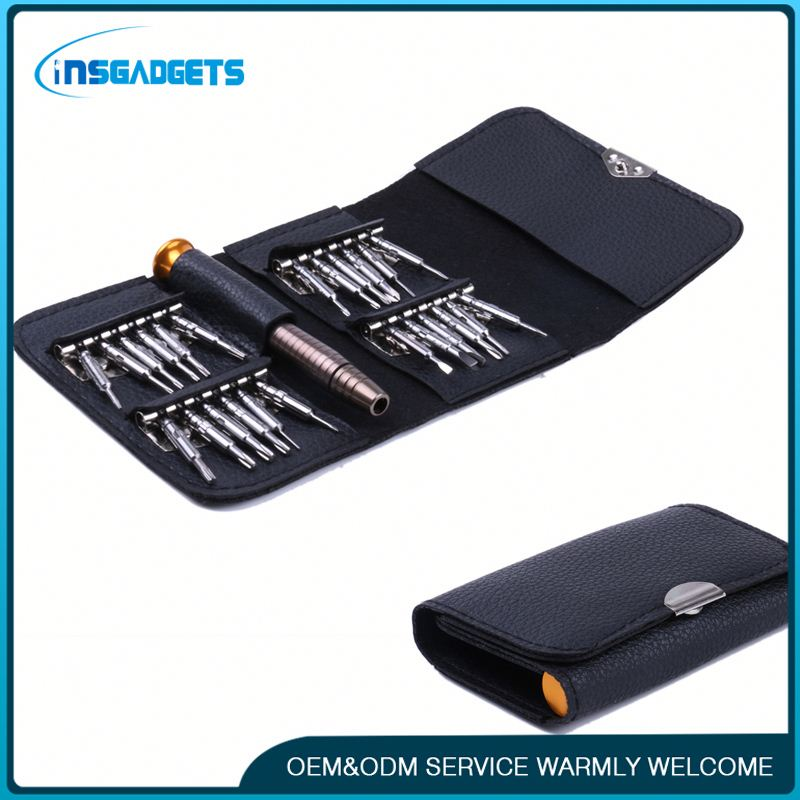What does the presence of the watermark indicate about the context in which this image is being used? The presence of the watermark 'INSGADGETS' on the image suggests that the photograph is likely utilized for promotional or commercial purposes. It indicates that INSGADGETS either produces or sells the screwdriver set depicted and is using the image to market their product. Additionally, the phrase 'OEM&ODM SERVICE WARMLY WELCOME' implies that the company is advertising its readiness to provide customized design and manufacturing services for other businesses, aiming to attract B2B (business-to-business) clients. This type of information is essential for businesses looking to know about the availability of personalized manufacturing solutions offered by INSGADGETS. 